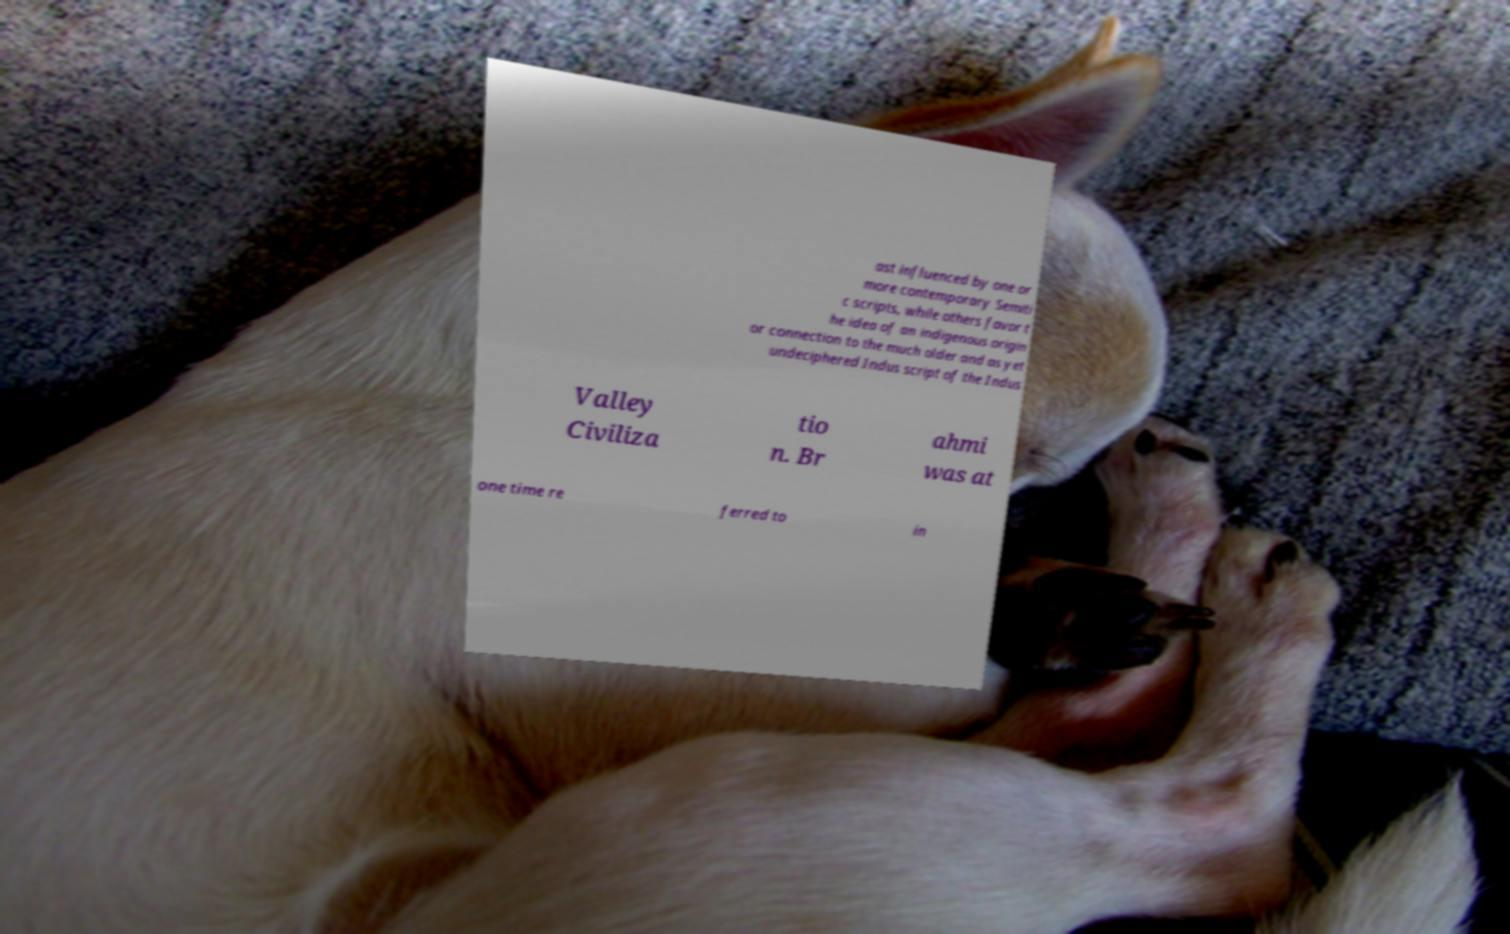Could you extract and type out the text from this image? ast influenced by one or more contemporary Semiti c scripts, while others favor t he idea of an indigenous origin or connection to the much older and as yet undeciphered Indus script of the Indus Valley Civiliza tio n. Br ahmi was at one time re ferred to in 